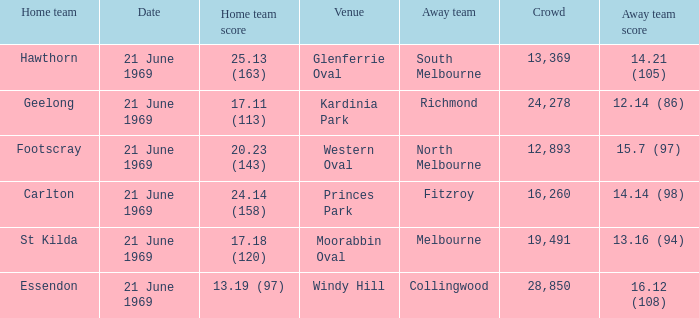When was there a game at Kardinia Park? 21 June 1969. 